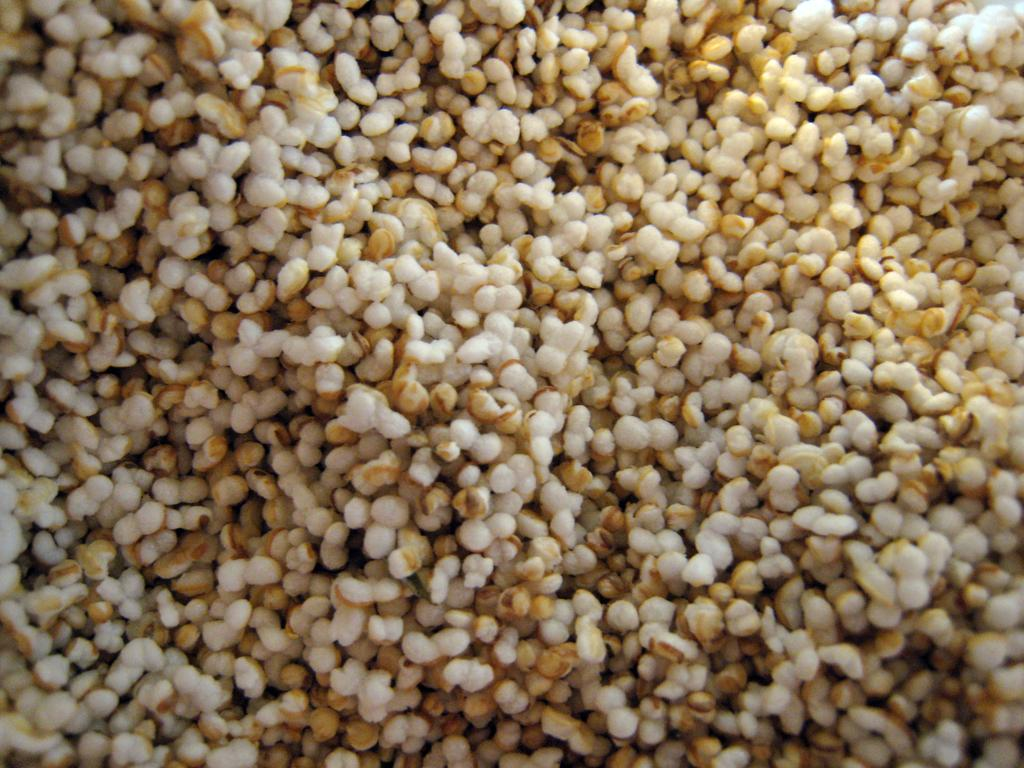What type of food or ingredient is visible in the image? There are grains in the image. What type of shirt is the creature wearing in the image? There is no creature or shirt present in the image; it only features grains. 